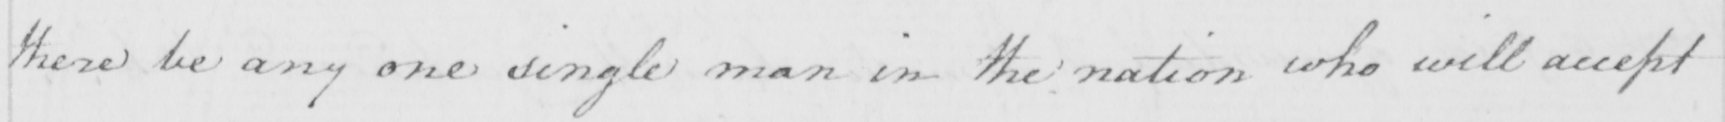Please provide the text content of this handwritten line. there be any one single man in the nation who will accept 